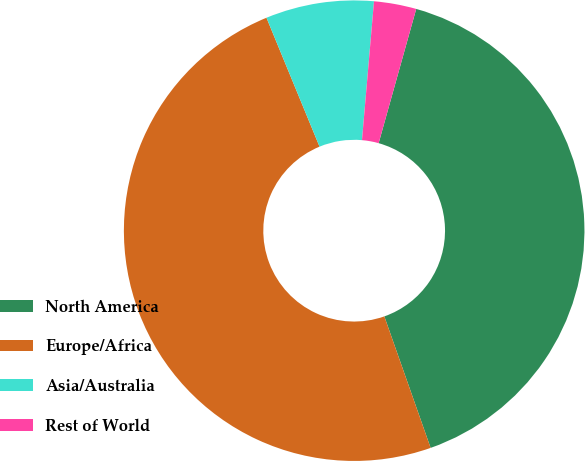Convert chart to OTSL. <chart><loc_0><loc_0><loc_500><loc_500><pie_chart><fcel>North America<fcel>Europe/Africa<fcel>Asia/Australia<fcel>Rest of World<nl><fcel>40.27%<fcel>49.17%<fcel>7.59%<fcel>2.97%<nl></chart> 